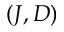Convert formula to latex. <formula><loc_0><loc_0><loc_500><loc_500>( J , D )</formula> 